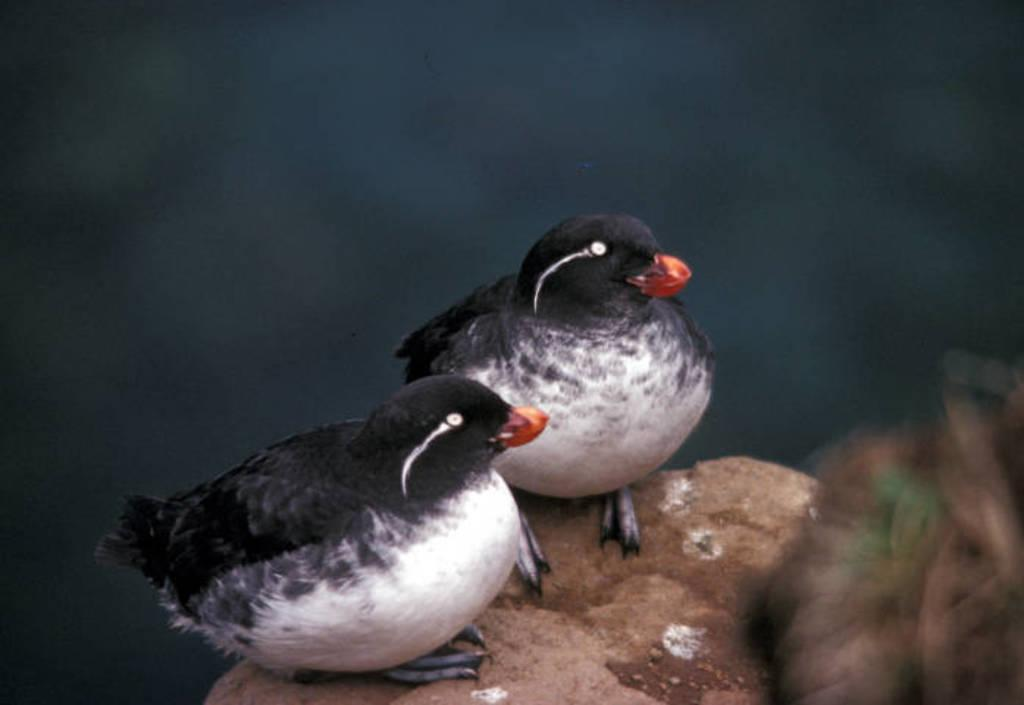How many birds are present in the image? There are 2 birds in the picture. What colors are the birds? The birds are black and white in color. What is the surface the birds are standing on? The birds are on a brown surface. Can you describe the background of the image? The background of the image is blurred. What type of engine can be seen powering the birds in the image? There is no engine present in the image, and the birds are not being powered by any external force. 